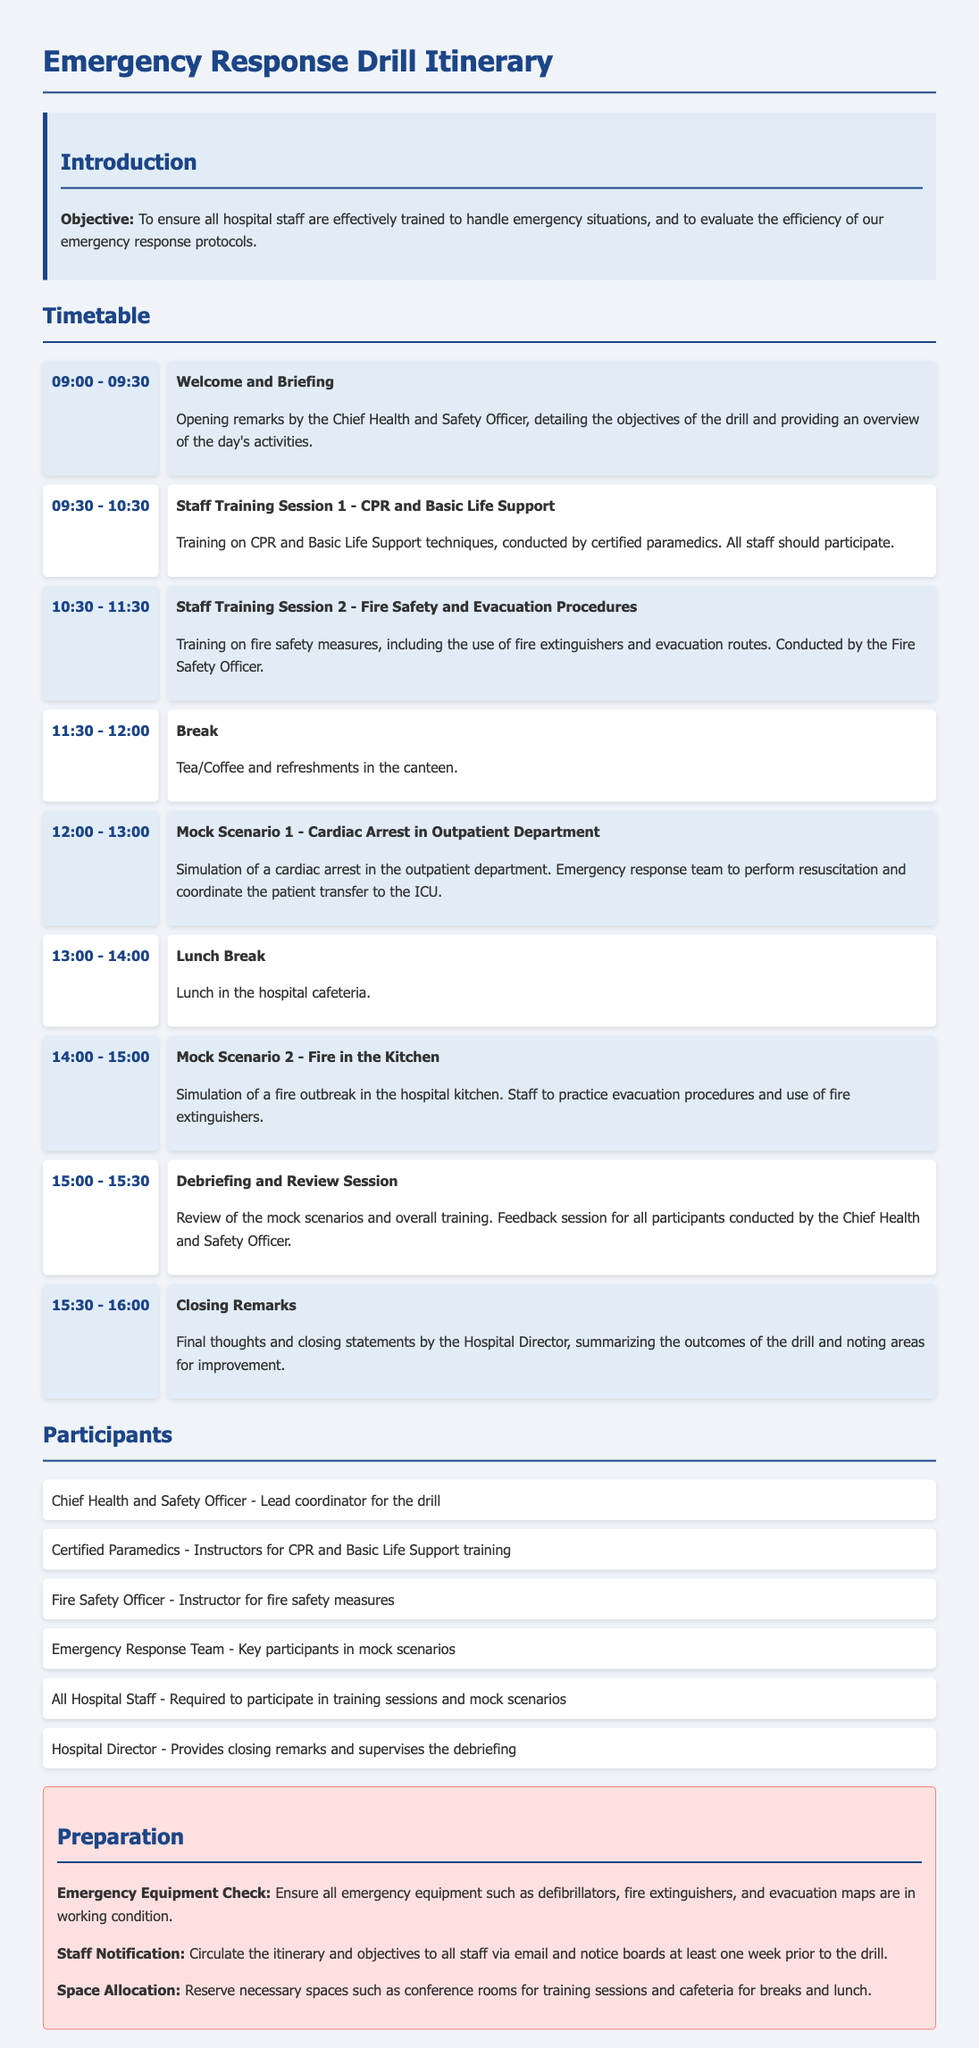What is the objective of the drill? The objective is to ensure all hospital staff are effectively trained to handle emergency situations and to evaluate the efficiency of our emergency response protocols.
Answer: To ensure all hospital staff are effectively trained to handle emergency situations, and to evaluate the efficiency of our emergency response protocols Who conducts the training on CPR and Basic Life Support? The training on CPR and Basic Life Support is conducted by certified paramedics.
Answer: Certified paramedics What time does the mock scenario for cardiac arrest begin? The mock scenario for cardiac arrest begins at 12:00.
Answer: 12:00 How long is the lunch break scheduled for? The lunch break is scheduled for one hour, from 13:00 to 14:00.
Answer: One hour What is the primary role of the Chief Health and Safety Officer during the drill? The Chief Health and Safety Officer is the lead coordinator for the drill.
Answer: Lead coordinator for the drill What activity follows the break at 11:30? The activity that follows the break at 11:30 is Mock Scenario 1 - Cardiac Arrest in Outpatient Department.
Answer: Mock Scenario 1 - Cardiac Arrest in Outpatient Department How many mock scenarios are included in the itinerary? There are two mock scenarios included in the itinerary.
Answer: Two Who provides the closing remarks at the end of the drill? The Hospital Director provides the closing remarks.
Answer: Hospital Director 